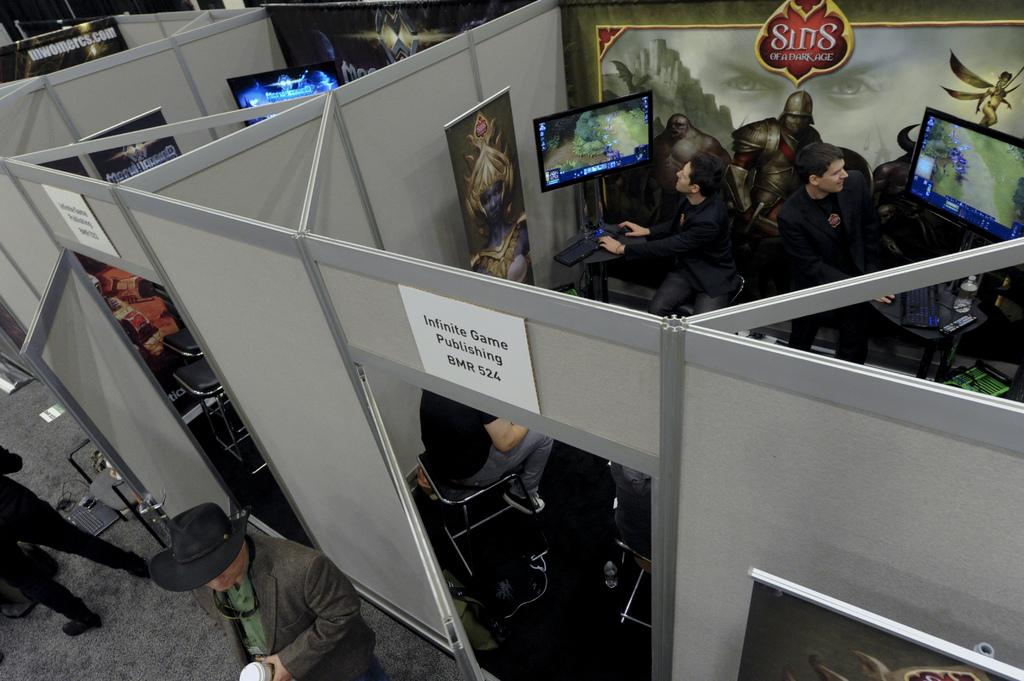<image>
Present a compact description of the photo's key features. A cubicle for video game playing has a sign over the door that says Infinite Game Publishing BMR 524. 